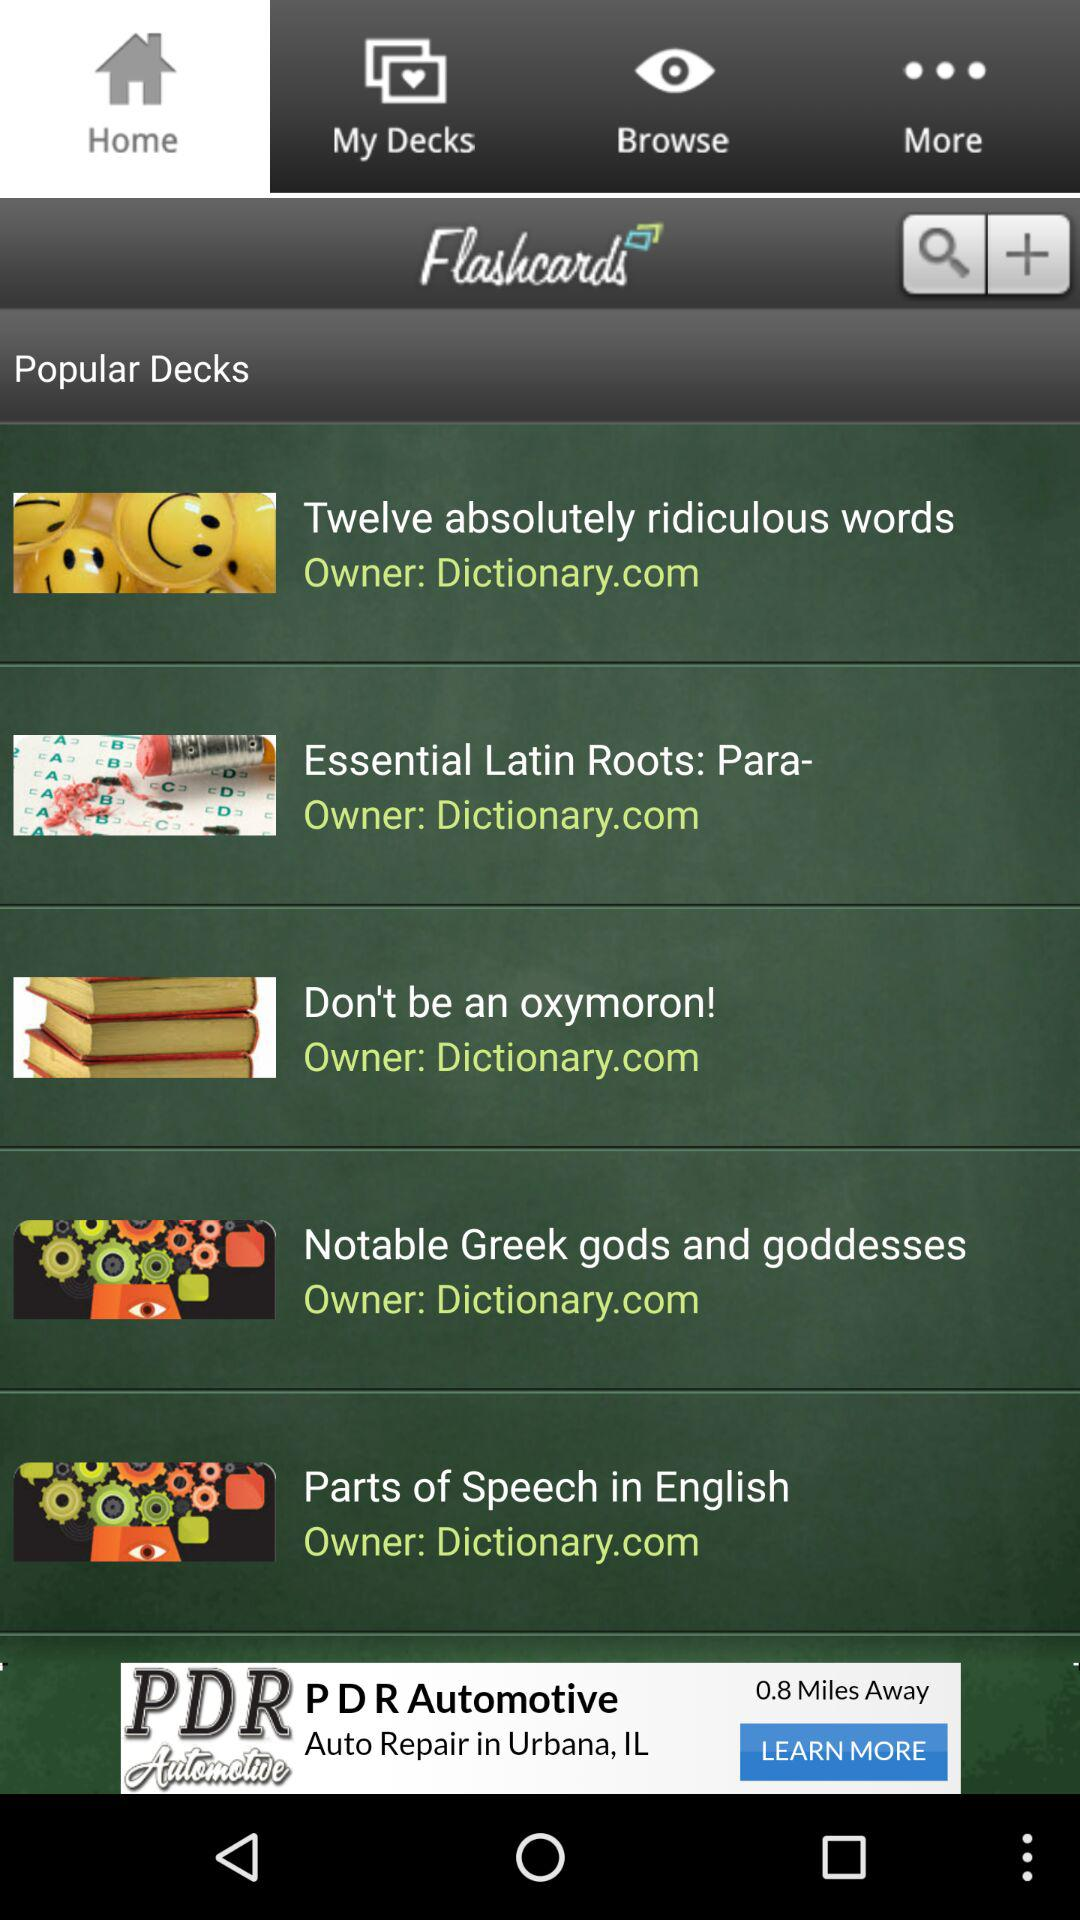Which tab is open? The open tab is "Home". 